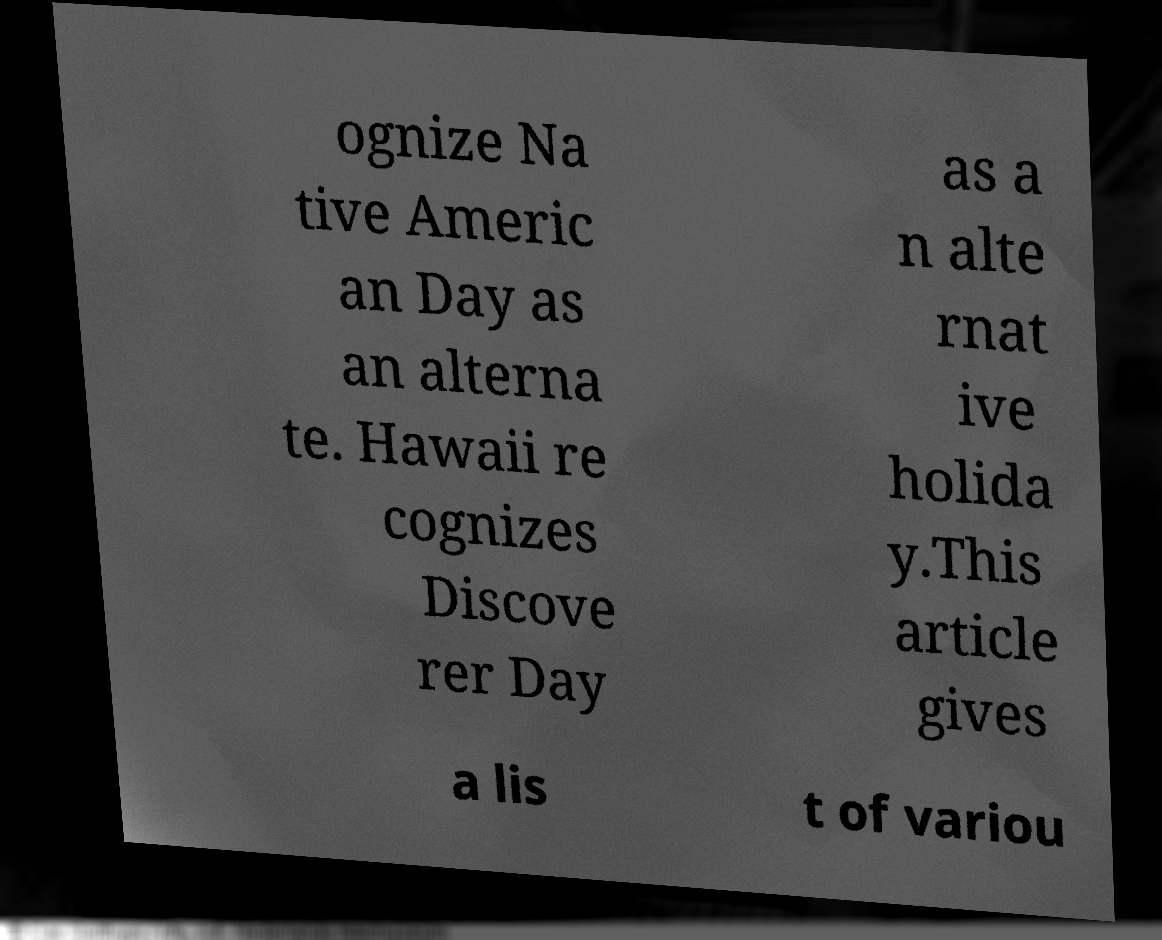Could you extract and type out the text from this image? ognize Na tive Americ an Day as an alterna te. Hawaii re cognizes Discove rer Day as a n alte rnat ive holida y.This article gives a lis t of variou 